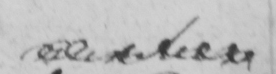Transcribe the text shown in this historical manuscript line. number 